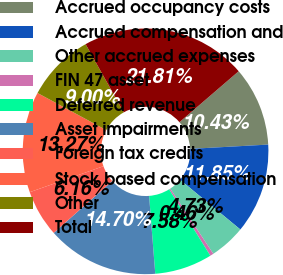Convert chart. <chart><loc_0><loc_0><loc_500><loc_500><pie_chart><fcel>Accrued occupancy costs<fcel>Accrued compensation and<fcel>Other accrued expenses<fcel>FIN 47 asset<fcel>Deferred revenue<fcel>Asset impairments<fcel>Foreign tax credits<fcel>Stock based compensation<fcel>Other<fcel>Total<nl><fcel>10.43%<fcel>11.85%<fcel>4.73%<fcel>0.46%<fcel>7.58%<fcel>14.7%<fcel>6.16%<fcel>13.27%<fcel>9.0%<fcel>21.81%<nl></chart> 